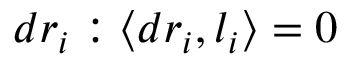<formula> <loc_0><loc_0><loc_500><loc_500>d r _ { i } \colon \langle d r _ { i } , l _ { i } \rangle = 0</formula> 